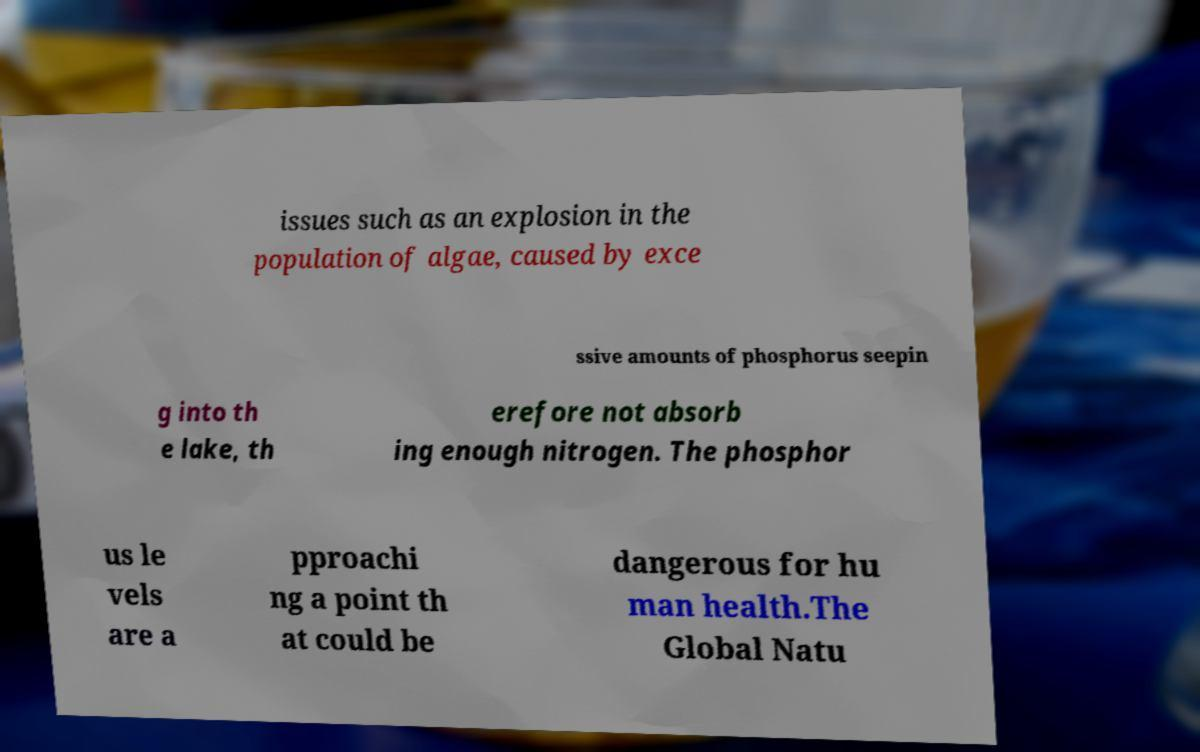Could you assist in decoding the text presented in this image and type it out clearly? issues such as an explosion in the population of algae, caused by exce ssive amounts of phosphorus seepin g into th e lake, th erefore not absorb ing enough nitrogen. The phosphor us le vels are a pproachi ng a point th at could be dangerous for hu man health.The Global Natu 